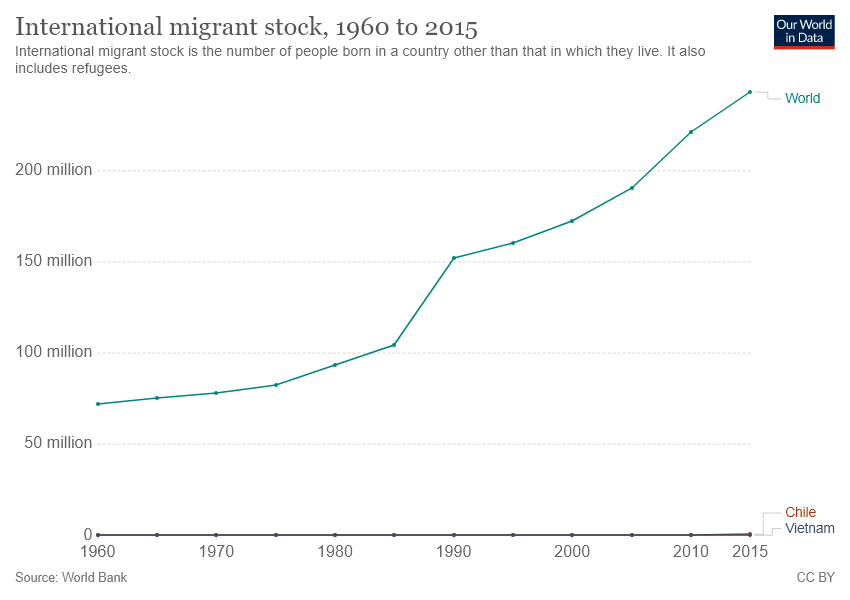Point out several critical features in this image. The graph displays the value of international migrant stock for different countries. The bar that shows the highest value is labeled as "World. According to the two-place show, the value of the international migrant stock in 2019 was 0 for Chile and Vietnam. 